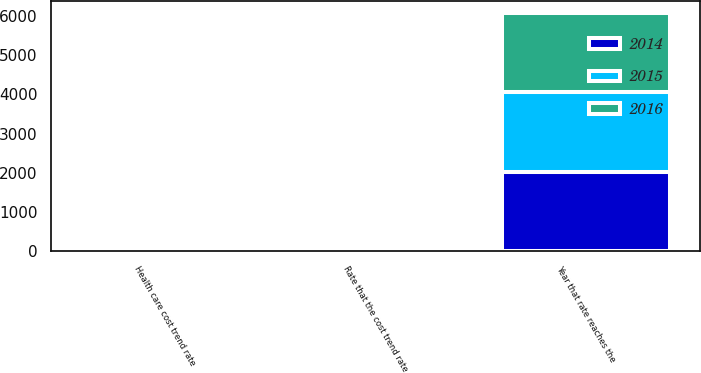Convert chart to OTSL. <chart><loc_0><loc_0><loc_500><loc_500><stacked_bar_chart><ecel><fcel>Health care cost trend rate<fcel>Rate that the cost trend rate<fcel>Year that rate reaches the<nl><fcel>2016<fcel>8<fcel>5<fcel>2027<nl><fcel>2015<fcel>8<fcel>5<fcel>2028<nl><fcel>2014<fcel>8<fcel>5<fcel>2025<nl></chart> 